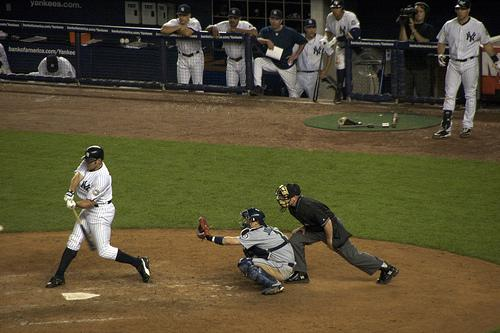Why does the kneeling man crouch low?

Choices:
A) catch ball
B) he's tired
C) wave hello
D) clean base catch ball 